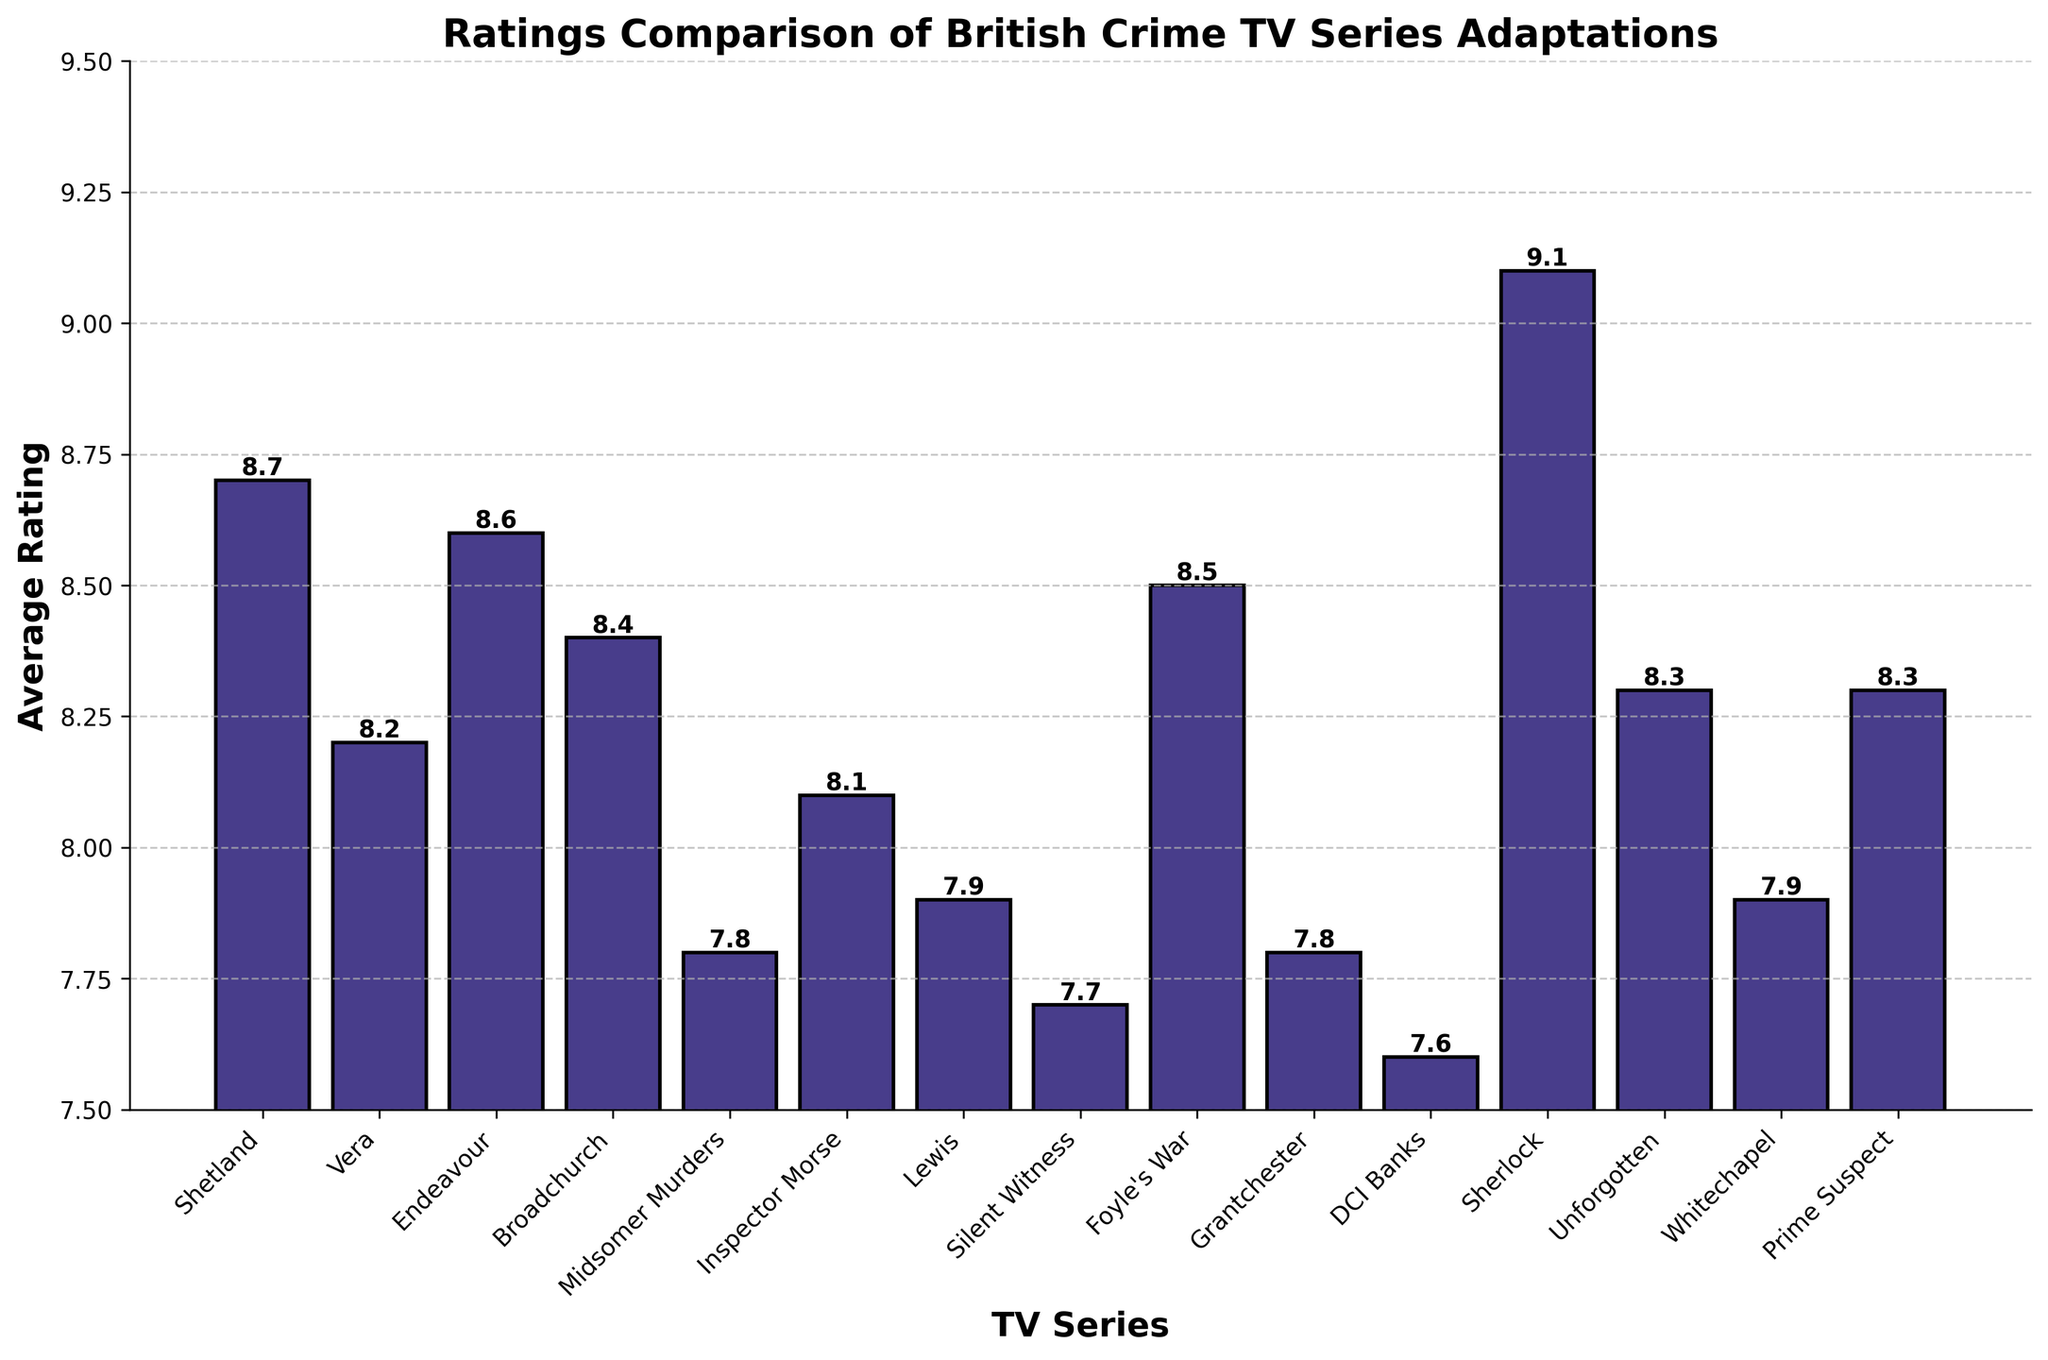Which TV series has the highest average rating? The TV series with the highest average rating is the one with the tallest bar in the chart. From the figure, the tallest bar is associated with 'Sherlock'.
Answer: Sherlock What is the average rating difference between Shetland and Vera? To find the difference, subtract the average rating of Vera from the average rating of Shetland. Shetland has a rating of 8.7, while Vera has a rating of 8.2. The difference is 8.7 - 8.2 = 0.5.
Answer: 0.5 How many TV series have an average rating of 8.3? Look at the bars corresponding to the value 8.3. There are two TV series with this rating: 'Unforgotten' and 'Prime Suspect'.
Answer: 2 Is the average rating of Broadchurch higher or lower than Foyle's War? Compare the height of the bars corresponding to Broadchurch and Foyle's War. Broadchurch has an average rating of 8.4, and Foyle's War has a rating of 8.5, making Broadchurch's rating lower than Foyle's War.
Answer: Lower Which TV series with ratings above 8.0 have the lowest average rating? Among the TV series with ratings above 8.0, find the bar corresponding to the lowest value. 'Inspector Morse' has the lowest rating among them, which is 8.1.
Answer: Inspector Morse How much higher is the average rating of 'Sherlock' compared to 'DCI Banks'? To find how much higher 'Sherlock's rating is, subtract the average rating of 'DCI Banks' from 'Sherlock'. The ratings are 9.1 for 'Sherlock' and 7.6 for 'DCI Banks'. The difference is 9.1 - 7.6 = 1.5.
Answer: 1.5 What is the median rating of all the listed TV series? First, list all ratings in ascending order: 7.6, 7.7, 7.8, 7.8, 7.9, 7.9, 8.1, 8.2, 8.3, 8.3, 8.4, 8.5, 8.6, 8.7, 9.1. The median is the middle value in this ordered list. With 15 series, the median is the 8th value, which is 8.3.
Answer: 8.3 What is the total number of TV series with an average rating above 8.5? Count the bars that are above the 8.5 rating mark. There are three series: 'Shetland', 'Endeavour', and 'Sherlock'.
Answer: 3 